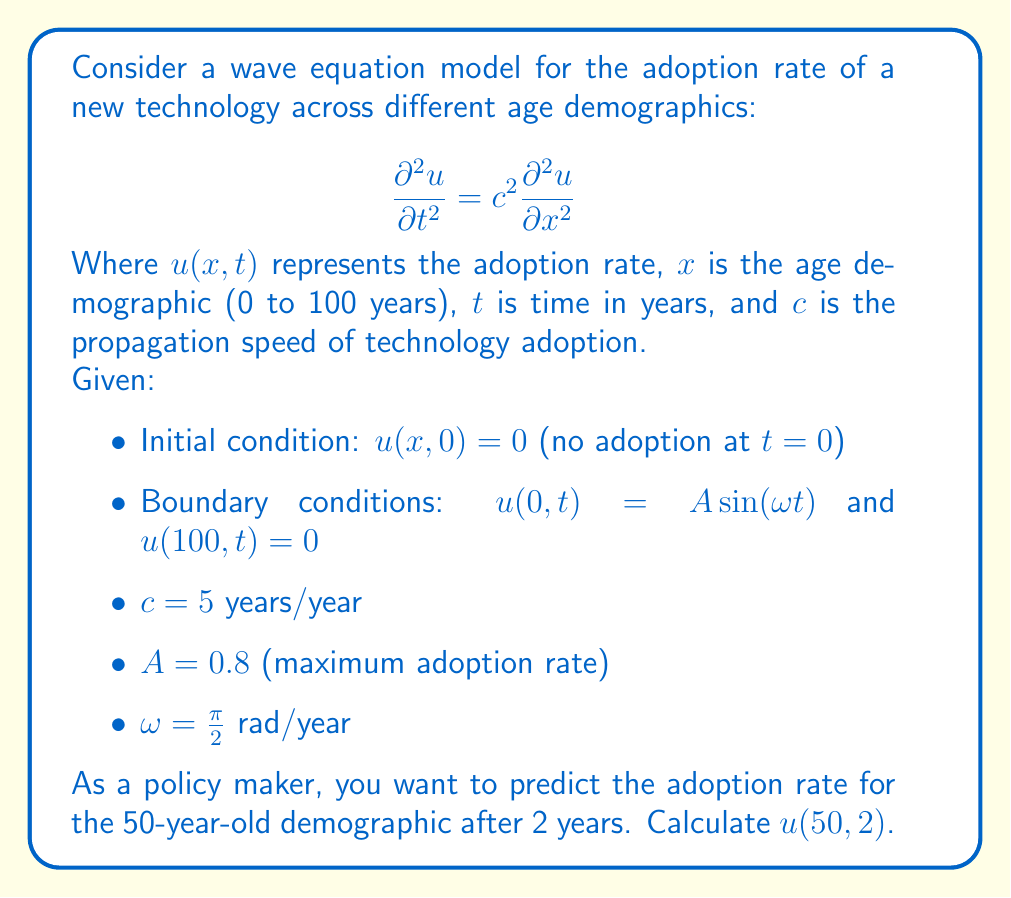Can you answer this question? To solve this problem, we need to use the method of separation of variables for the wave equation with the given initial and boundary conditions.

1) Assume a solution of the form $u(x,t) = X(x)T(t)$

2) Substituting into the wave equation:
   $$X(x)T''(t) = c^2X''(x)T(t)$$
   $$\frac{T''(t)}{c^2T(t)} = \frac{X''(x)}{X(x)} = -k^2$$

3) This gives us two ordinary differential equations:
   $$T''(t) + c^2k^2T(t) = 0$$
   $$X''(x) + k^2X(x) = 0$$

4) The general solutions are:
   $$T(t) = E\cos(ckt) + F\sin(ckt)$$
   $$X(x) = G\cos(kx) + H\sin(kx)$$

5) Applying the boundary conditions:
   $u(0,t) = A\sin(\omega t)$ implies $X(0) = 0$ and $T(t) = A\sin(\omega t)$
   $u(100,t) = 0$ implies $X(100) = 0$

6) From $X(0) = 0$, we get $G = 0$, so $X(x) = H\sin(kx)$
   From $X(100) = 0$, we get $k = \frac{n\pi}{100}$ where $n$ is a positive integer

7) The general solution is:
   $$u(x,t) = \sum_{n=1}^{\infty} B_n \sin(\frac{n\pi x}{100})\sin(\frac{n\pi ct}{100})$$

8) To match the boundary condition at $x=0$:
   $$A\sin(\omega t) = \sum_{n=1}^{\infty} B_n \sin(\frac{n\pi ct}{100})$$

9) This implies $\omega = \frac{\pi c}{100} = \frac{\pi}{20}$ (given $c=5$)
   And $B_n = 0$ for all $n$ except $n=1$, where $B_1 = A = 0.8$

10) Therefore, the solution is:
    $$u(x,t) = 0.8 \sin(\frac{\pi x}{100})\sin(\frac{\pi t}{20})$$

11) To find $u(50,2)$, we substitute $x=50$ and $t=2$:
    $$u(50,2) = 0.8 \sin(\frac{\pi 50}{100})\sin(\frac{\pi 2}{20})$$
    $$= 0.8 \sin(\frac{\pi}{2})\sin(\frac{\pi}{10})$$
    $$= 0.8 \cdot 1 \cdot \sin(\frac{\pi}{10})$$
    $$\approx 0.8 \cdot 0.3090 \approx 0.2472$$
Answer: $u(50,2) \approx 0.2472$ 